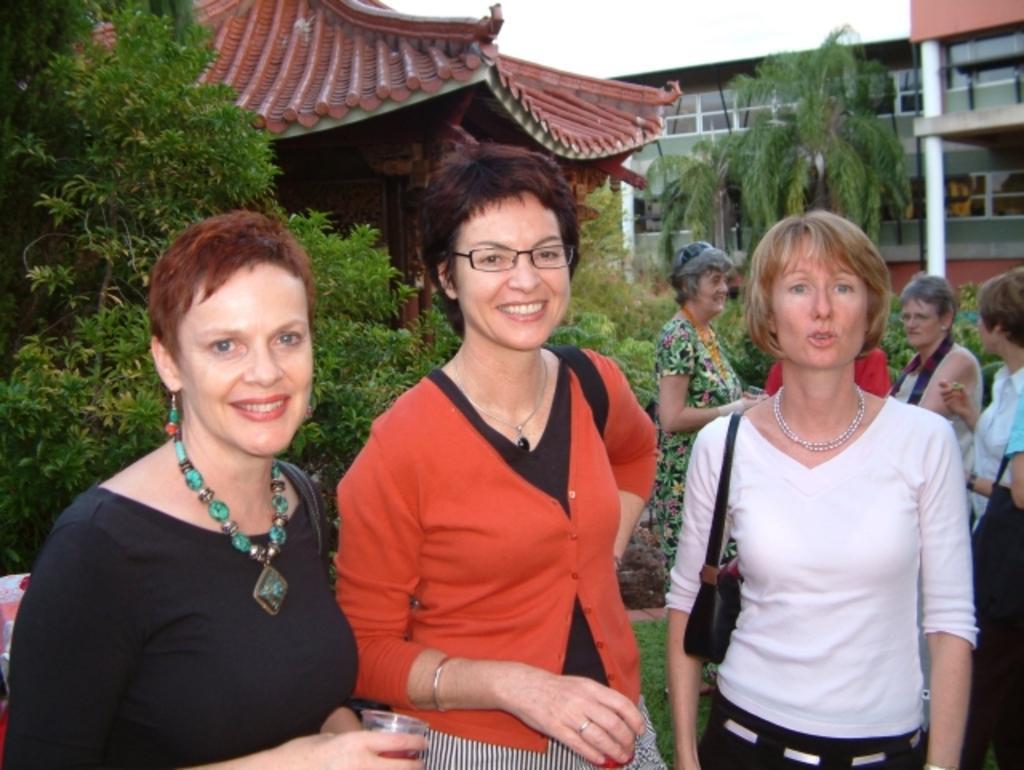In one or two sentences, can you explain what this image depicts? In this image there are three women are standing on the grassland. Woman wearing a black top is holding a glass in her hand. Woman wearing white top is carrying bag. Woman at the middle of image is having spectacles. Right side there are few persons standing on the grass land. Behind them there are few plants, trees. Behind it there are few buildings. Top of it there is sky. 